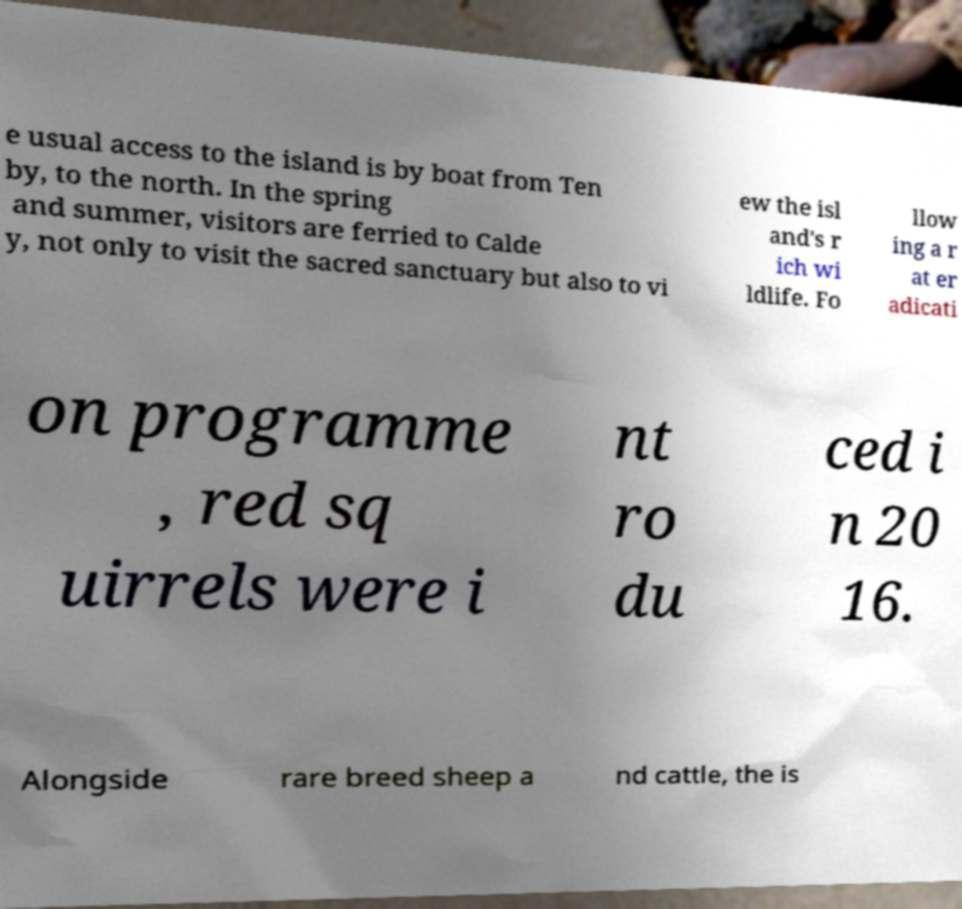For documentation purposes, I need the text within this image transcribed. Could you provide that? e usual access to the island is by boat from Ten by, to the north. In the spring and summer, visitors are ferried to Calde y, not only to visit the sacred sanctuary but also to vi ew the isl and's r ich wi ldlife. Fo llow ing a r at er adicati on programme , red sq uirrels were i nt ro du ced i n 20 16. Alongside rare breed sheep a nd cattle, the is 